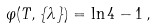<formula> <loc_0><loc_0><loc_500><loc_500>\varphi ( T , \{ \lambda \} ) = \ln 4 - 1 \, ,</formula> 